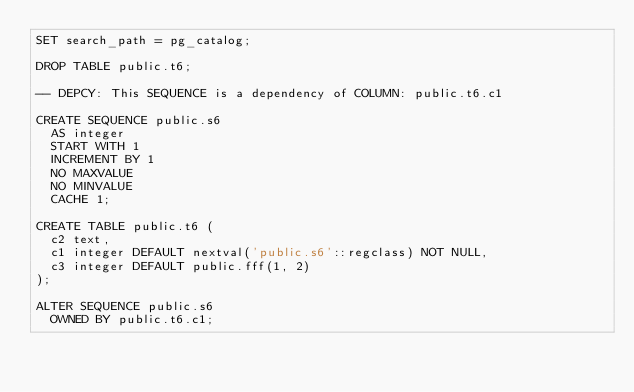<code> <loc_0><loc_0><loc_500><loc_500><_SQL_>SET search_path = pg_catalog;

DROP TABLE public.t6;

-- DEPCY: This SEQUENCE is a dependency of COLUMN: public.t6.c1

CREATE SEQUENCE public.s6
	AS integer
	START WITH 1
	INCREMENT BY 1
	NO MAXVALUE
	NO MINVALUE
	CACHE 1;

CREATE TABLE public.t6 (
	c2 text,
	c1 integer DEFAULT nextval('public.s6'::regclass) NOT NULL,
	c3 integer DEFAULT public.fff(1, 2)
);

ALTER SEQUENCE public.s6
	OWNED BY public.t6.c1;
</code> 